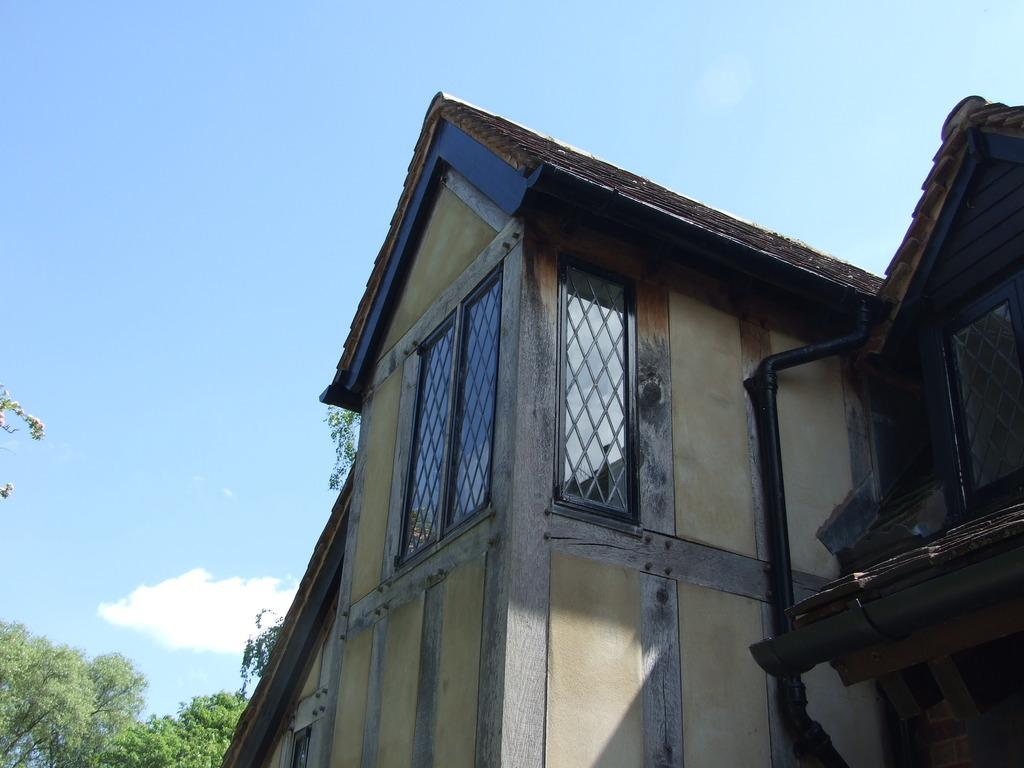What can be seen in the background of the image? There is a sky in the image, with clouds visible. What type of natural elements are present in the image? There are trees in the image. How many structures can be seen in the image? There is one building in the image, along with a wall and a roof. What architectural features are present on the building? There are windows in the image. Can you describe the woman taking a bath in the image? There is no woman taking a bath in the image. What type of trail can be seen in the image? There is no trail present in the image. 